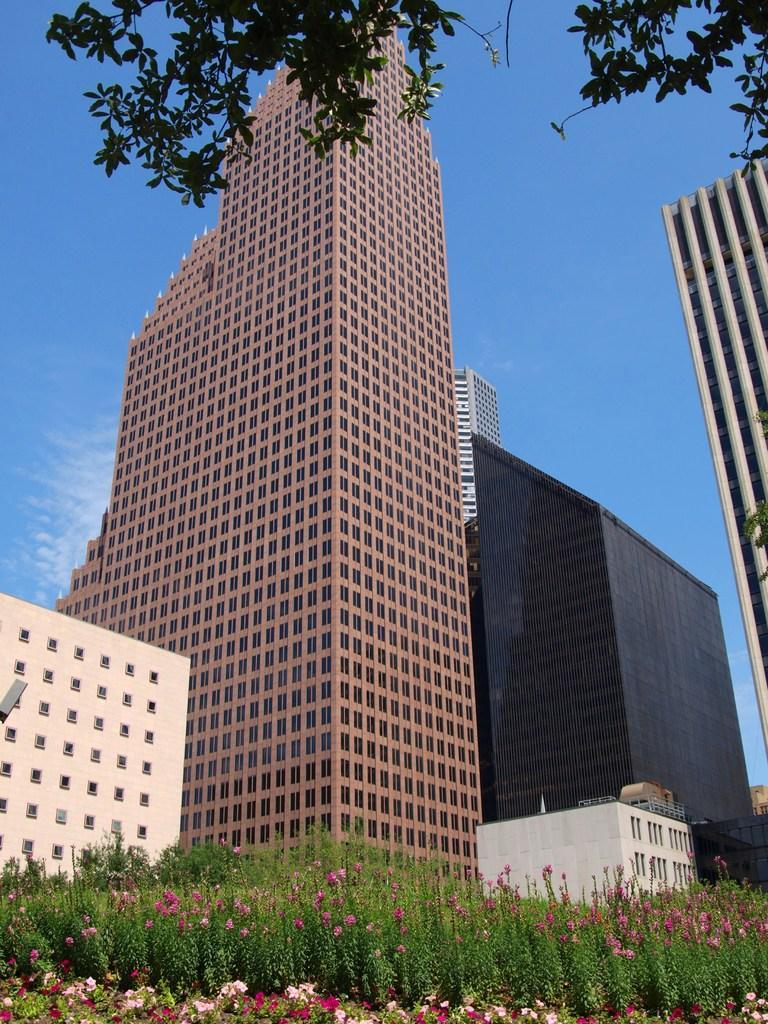Can you describe this image briefly? In this picture we can see there are buildings. Behind the buildings, there is the sky. At the bottom of the image, there are plants. At the top of the image, there is a tree. 